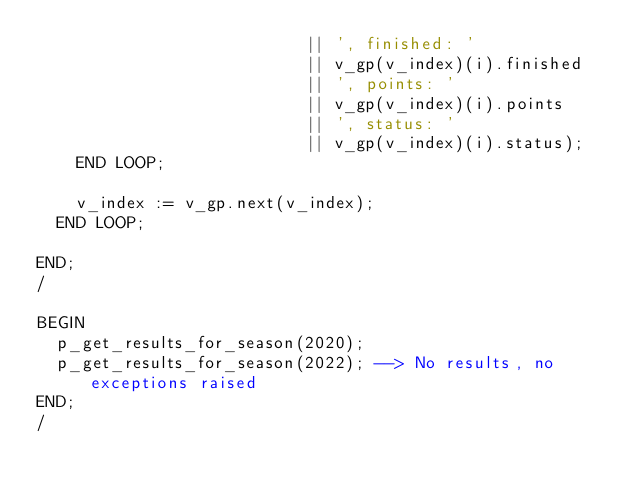<code> <loc_0><loc_0><loc_500><loc_500><_SQL_>                           || ', finished: '
                           || v_gp(v_index)(i).finished
                           || ', points: '
                           || v_gp(v_index)(i).points
                           || ', status: '
                           || v_gp(v_index)(i).status);
    END LOOP;

    v_index := v_gp.next(v_index);
  END LOOP;

END;
/

BEGIN
  p_get_results_for_season(2020);
  p_get_results_for_season(2022); --> No results, no exceptions raised
END;
/
</code> 